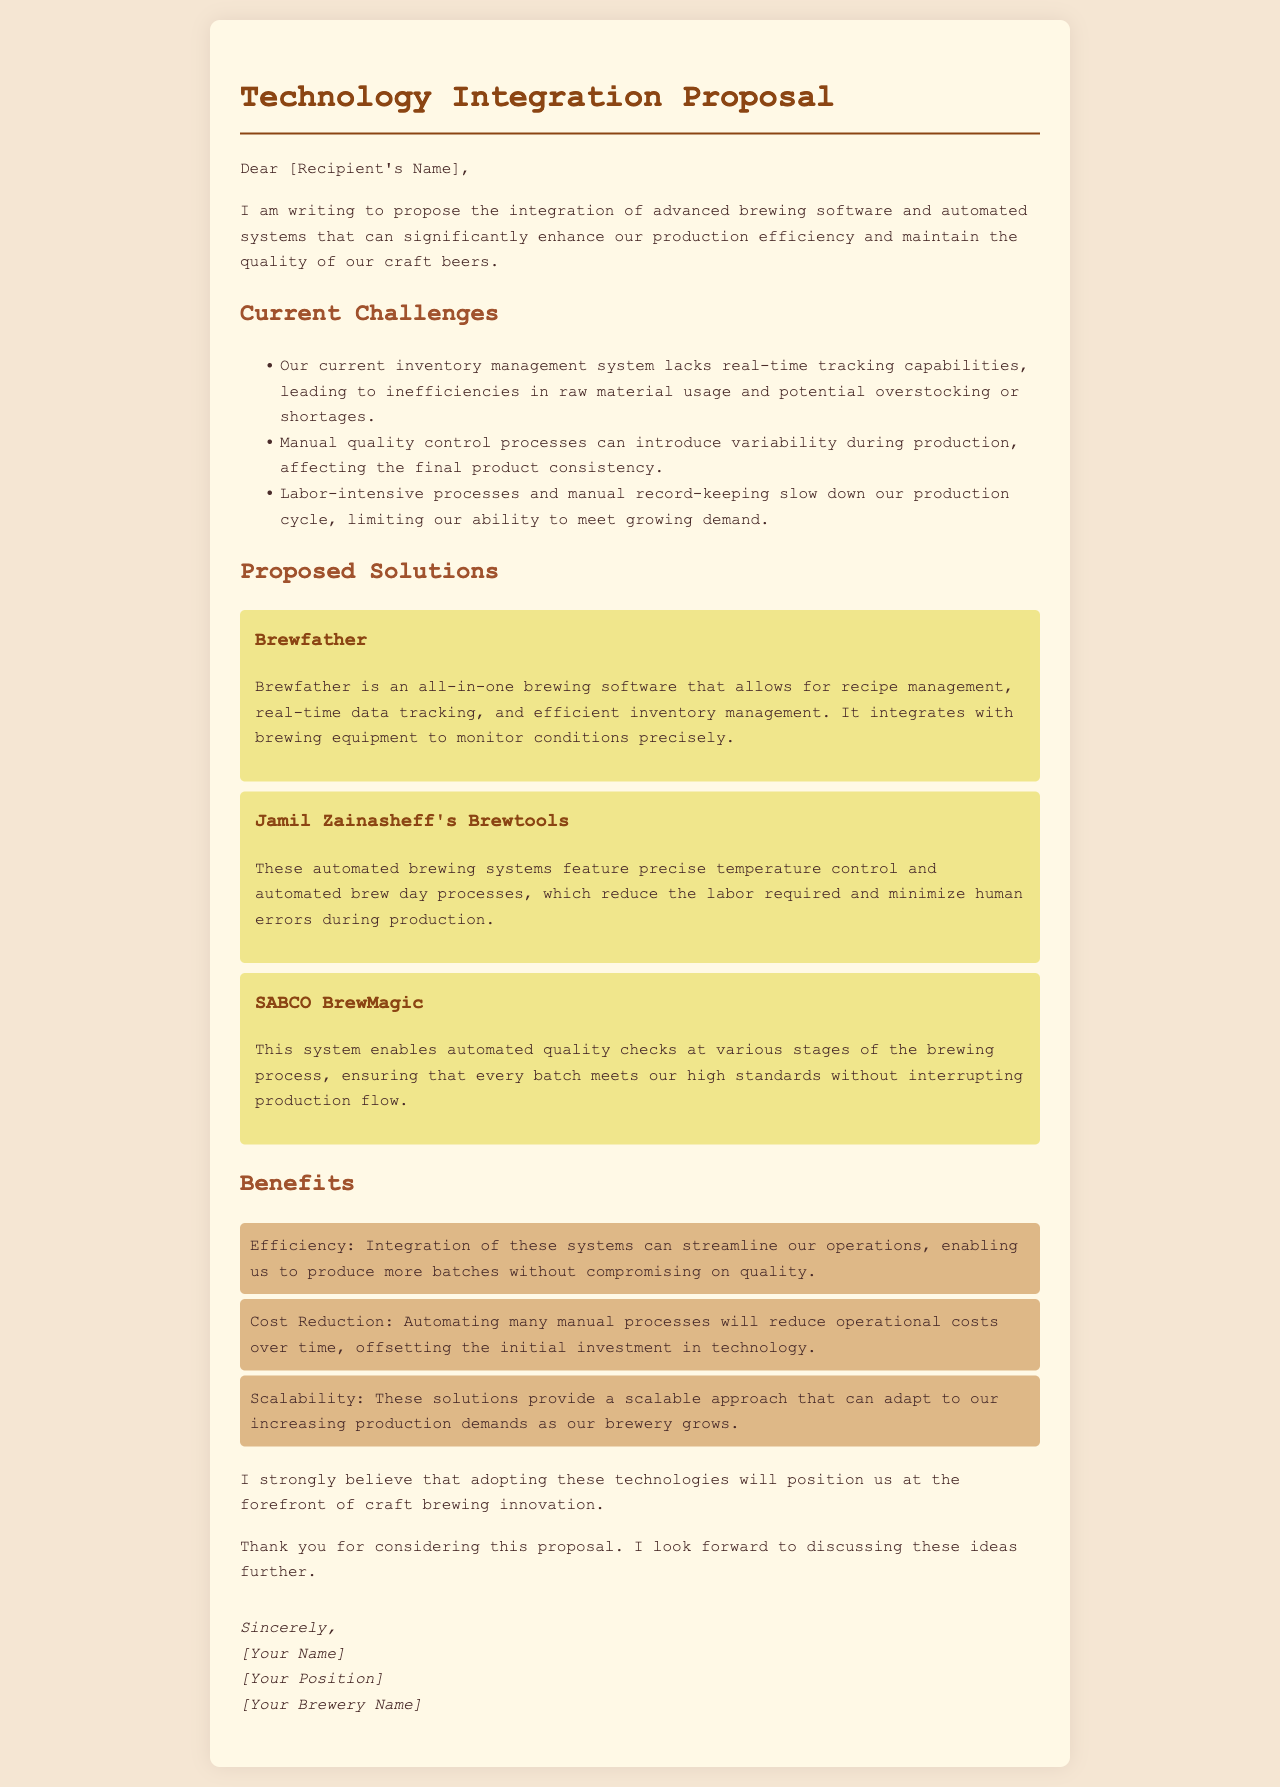What is the title of the proposal? The title of the proposal is stated at the beginning of the document.
Answer: Technology Integration Proposal Who is the proposed software by? The software mentioned in the proposal is attributed to specific names or brands.
Answer: Brewfather What is one of the current challenges mentioned? The current challenges section lists specific issues faced in the brewing process.
Answer: Inventory management system lacks real-time tracking capabilities What type of system is Brewtools? Brewtools is described within the proposed solutions section of the document.
Answer: Automated brewing system What benefit involves operational costs? The benefits section outlines advantages provided by the proposed technology, including financial aspects.
Answer: Cost Reduction How many proposed solutions are listed? The document includes a specific number of proposed solutions for technology integration.
Answer: Three What is the effect of integrating these systems on production? The proposal states the expected result of adopting the new technology on production capabilities.
Answer: Streamline operations Who authored the proposal? The signature section at the end of the document reveals the author of the proposal.
Answer: [Your Name] 